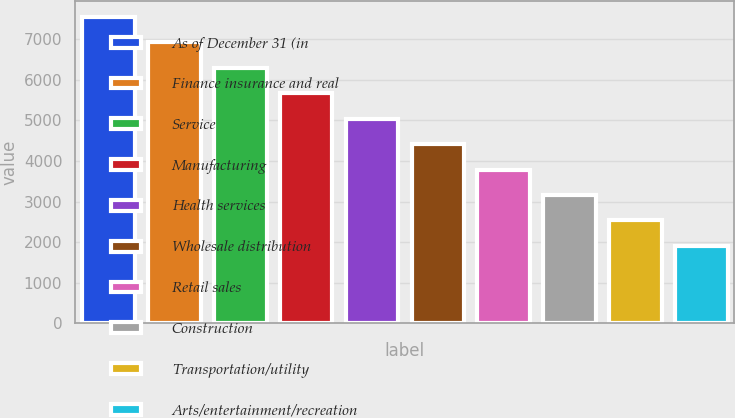Convert chart. <chart><loc_0><loc_0><loc_500><loc_500><bar_chart><fcel>As of December 31 (in<fcel>Finance insurance and real<fcel>Service<fcel>Manufacturing<fcel>Health services<fcel>Wholesale distribution<fcel>Retail sales<fcel>Construction<fcel>Transportation/utility<fcel>Arts/entertainment/recreation<nl><fcel>7557.82<fcel>6929.96<fcel>6302.1<fcel>5674.24<fcel>5046.38<fcel>4418.52<fcel>3790.66<fcel>3162.8<fcel>2534.94<fcel>1907.08<nl></chart> 